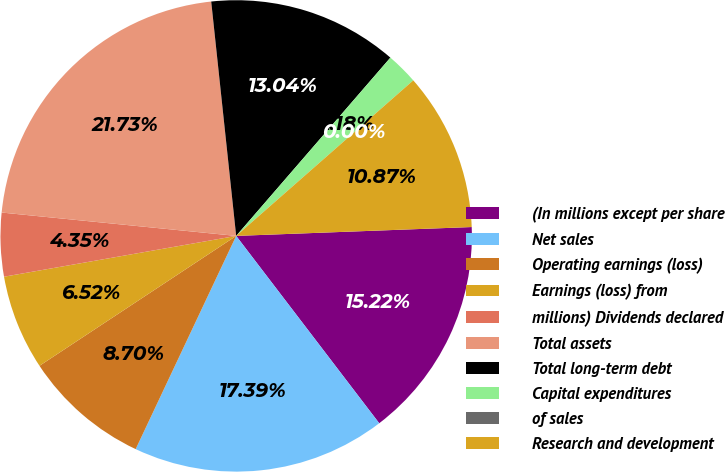<chart> <loc_0><loc_0><loc_500><loc_500><pie_chart><fcel>(In millions except per share<fcel>Net sales<fcel>Operating earnings (loss)<fcel>Earnings (loss) from<fcel>millions) Dividends declared<fcel>Total assets<fcel>Total long-term debt<fcel>Capital expenditures<fcel>of sales<fcel>Research and development<nl><fcel>15.22%<fcel>17.39%<fcel>8.7%<fcel>6.52%<fcel>4.35%<fcel>21.73%<fcel>13.04%<fcel>2.18%<fcel>0.0%<fcel>10.87%<nl></chart> 